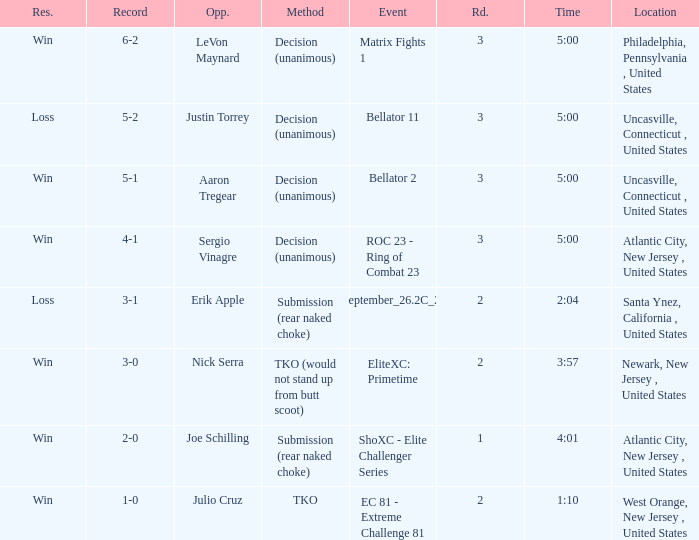Who was the opponent when there was a TKO method? Julio Cruz. 